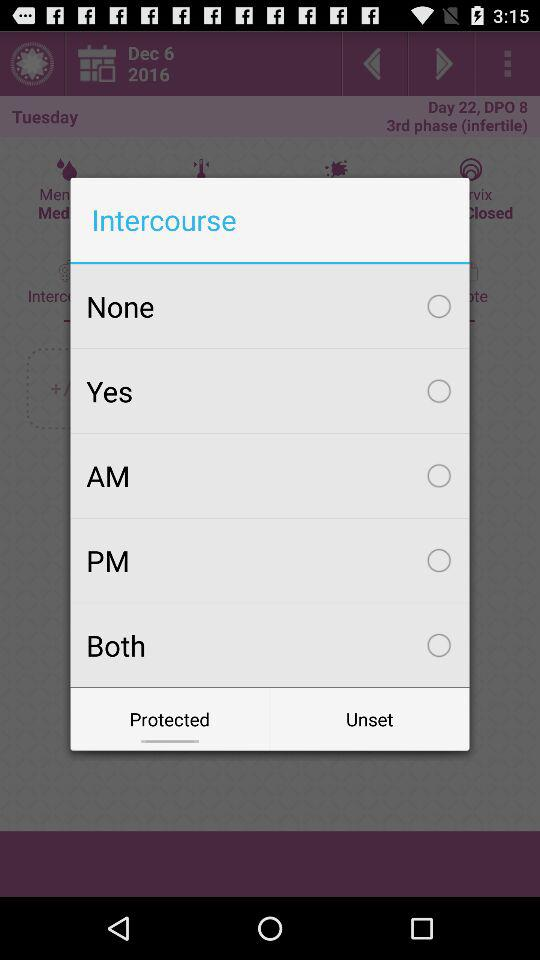On which tab are we? You are on the "Protected" tab. 